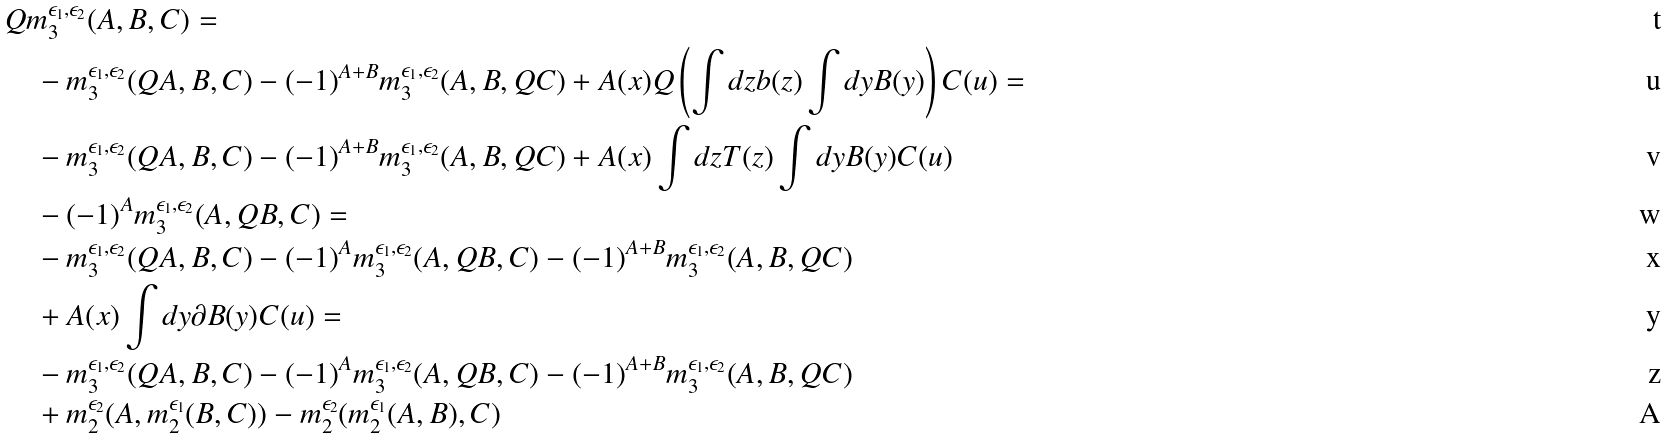Convert formula to latex. <formula><loc_0><loc_0><loc_500><loc_500>& Q m _ { 3 } ^ { \epsilon _ { 1 } , \epsilon _ { 2 } } ( A , B , C ) = \\ & \quad - m _ { 3 } ^ { \epsilon _ { 1 } , \epsilon _ { 2 } } ( Q A , B , C ) - ( - 1 ) ^ { A + B } m _ { 3 } ^ { \epsilon _ { 1 } , \epsilon _ { 2 } } ( A , B , Q C ) + A ( x ) Q \left ( \int d z b ( z ) \int d y B ( y ) \right ) C ( u ) = \\ & \quad - m _ { 3 } ^ { \epsilon _ { 1 } , \epsilon _ { 2 } } ( Q A , B , C ) - ( - 1 ) ^ { A + B } m _ { 3 } ^ { \epsilon _ { 1 } , \epsilon _ { 2 } } ( A , B , Q C ) + A ( x ) \int d z T ( z ) \int d y B ( y ) C ( u ) \\ & \quad - ( - 1 ) ^ { A } m _ { 3 } ^ { \epsilon _ { 1 } , \epsilon _ { 2 } } ( A , Q B , C ) = \\ & \quad - m _ { 3 } ^ { \epsilon _ { 1 } , \epsilon _ { 2 } } ( Q A , B , C ) - ( - 1 ) ^ { A } m _ { 3 } ^ { \epsilon _ { 1 } , \epsilon _ { 2 } } ( A , Q B , C ) - ( - 1 ) ^ { A + B } m _ { 3 } ^ { \epsilon _ { 1 } , \epsilon _ { 2 } } ( A , B , Q C ) \\ & \quad + A ( x ) \int d y \partial B ( y ) C ( u ) = \\ & \quad - m _ { 3 } ^ { \epsilon _ { 1 } , \epsilon _ { 2 } } ( Q A , B , C ) - ( - 1 ) ^ { A } m _ { 3 } ^ { \epsilon _ { 1 } , \epsilon _ { 2 } } ( A , Q B , C ) - ( - 1 ) ^ { A + B } m _ { 3 } ^ { \epsilon _ { 1 } , \epsilon _ { 2 } } ( A , B , Q C ) \\ & \quad + m _ { 2 } ^ { \epsilon _ { 2 } } ( A , m _ { 2 } ^ { \epsilon _ { 1 } } ( B , C ) ) - m _ { 2 } ^ { \epsilon _ { 2 } } ( m _ { 2 } ^ { \epsilon _ { 1 } } ( A , B ) , C )</formula> 